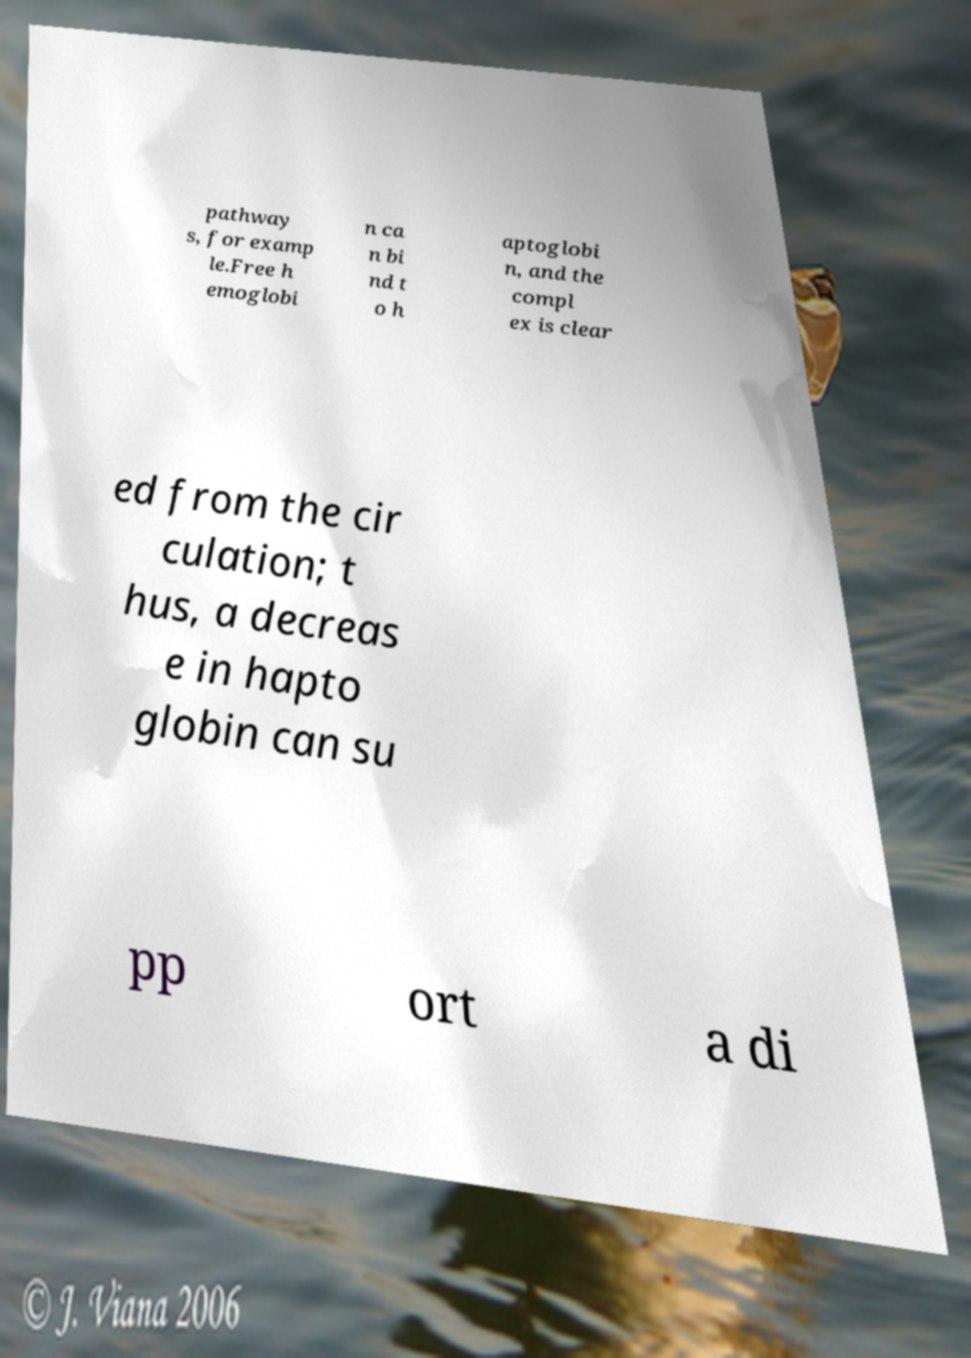Could you assist in decoding the text presented in this image and type it out clearly? pathway s, for examp le.Free h emoglobi n ca n bi nd t o h aptoglobi n, and the compl ex is clear ed from the cir culation; t hus, a decreas e in hapto globin can su pp ort a di 